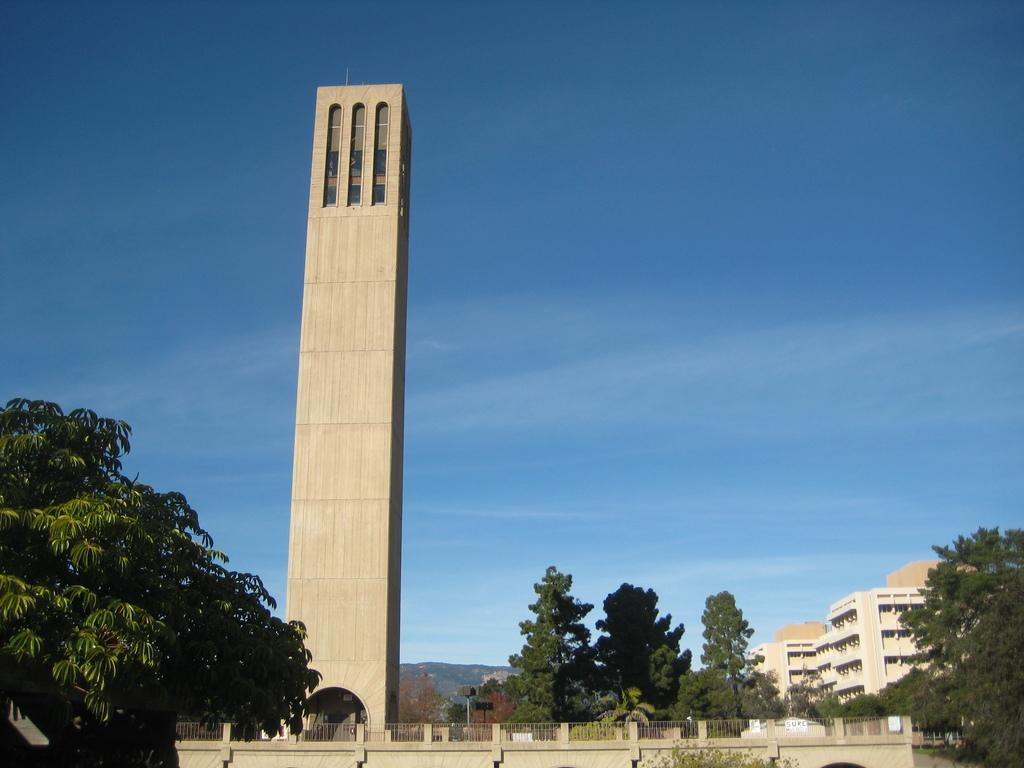What types of structures are located at the bottom of the image? There are trees and buildings at the bottom of the image. What is the main feature in the middle of the image? There is a tower in the middle of the image. What can be seen in the background of the image? The sky is visible in the background of the image. Can you tell me how many achievers are depicted in the image? There is no reference to achievers in the image, so it is not possible to answer that question. What type of ocean can be seen in the image? There is no ocean present in the image; it features trees, buildings, a tower, and the sky. 